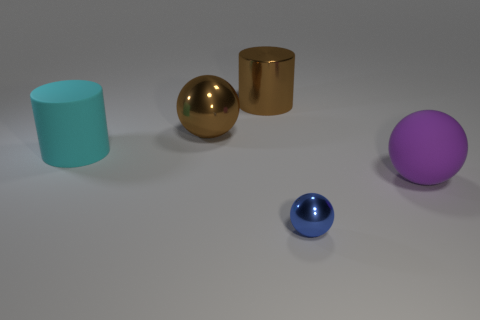How many small blue balls have the same material as the large purple thing?
Keep it short and to the point. 0. There is a large matte thing that is right of the matte thing that is left of the small shiny thing; is there a large purple object that is right of it?
Provide a short and direct response. No. There is a brown thing that is the same material as the big brown sphere; what is its shape?
Ensure brevity in your answer.  Cylinder. Is the number of purple objects greater than the number of blue cubes?
Offer a very short reply. Yes. There is a large purple matte thing; does it have the same shape as the big rubber object to the left of the brown cylinder?
Your response must be concise. No. What is the material of the cyan thing?
Offer a very short reply. Rubber. What color is the large sphere right of the small metallic ball right of the shiny ball that is behind the small blue metal sphere?
Keep it short and to the point. Purple. There is a large purple object that is the same shape as the tiny blue thing; what is its material?
Make the answer very short. Rubber. What number of other purple matte objects are the same size as the purple matte object?
Your answer should be very brief. 0. How many brown cylinders are there?
Keep it short and to the point. 1. 